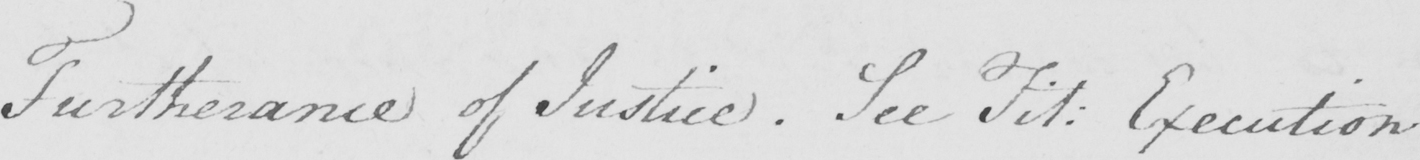Can you tell me what this handwritten text says? Furtherance of Justice . See Fit :  Execution . 